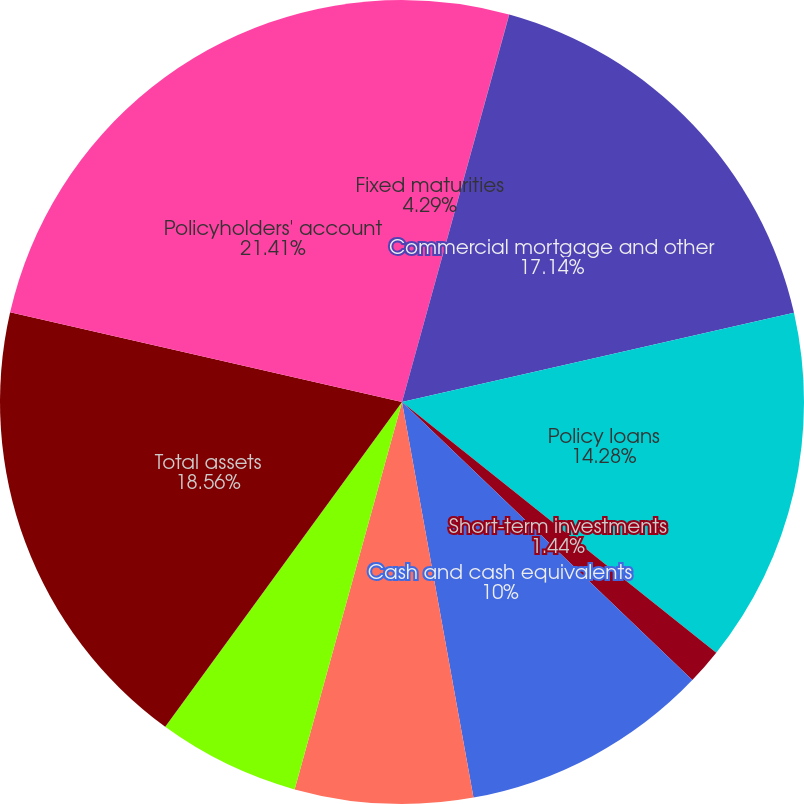Convert chart. <chart><loc_0><loc_0><loc_500><loc_500><pie_chart><fcel>Fixed maturities<fcel>Trading account assets<fcel>Commercial mortgage and other<fcel>Policy loans<fcel>Short-term investments<fcel>Cash and cash equivalents<fcel>Accrued investment income<fcel>Other assets<fcel>Total assets<fcel>Policyholders' account<nl><fcel>4.29%<fcel>0.01%<fcel>17.14%<fcel>14.28%<fcel>1.44%<fcel>10.0%<fcel>7.15%<fcel>5.72%<fcel>18.56%<fcel>21.42%<nl></chart> 